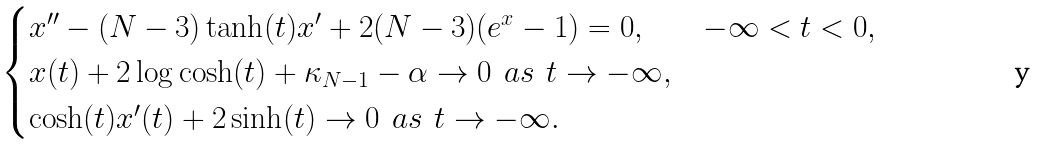<formula> <loc_0><loc_0><loc_500><loc_500>\begin{cases} x ^ { \prime \prime } - ( N - 3 ) \tanh ( t ) x ^ { \prime } + 2 ( N - 3 ) ( e ^ { x } - 1 ) = 0 , & - \infty < t < 0 , \\ x ( t ) + 2 \log \cosh ( t ) + \kappa _ { N - 1 } - \alpha \rightarrow 0 \ \ a s \ \ t \rightarrow - \infty , \\ \cosh ( t ) x ^ { \prime } ( t ) + 2 \sinh ( t ) \rightarrow 0 \ \ a s \ \ t \rightarrow - \infty . \end{cases}</formula> 